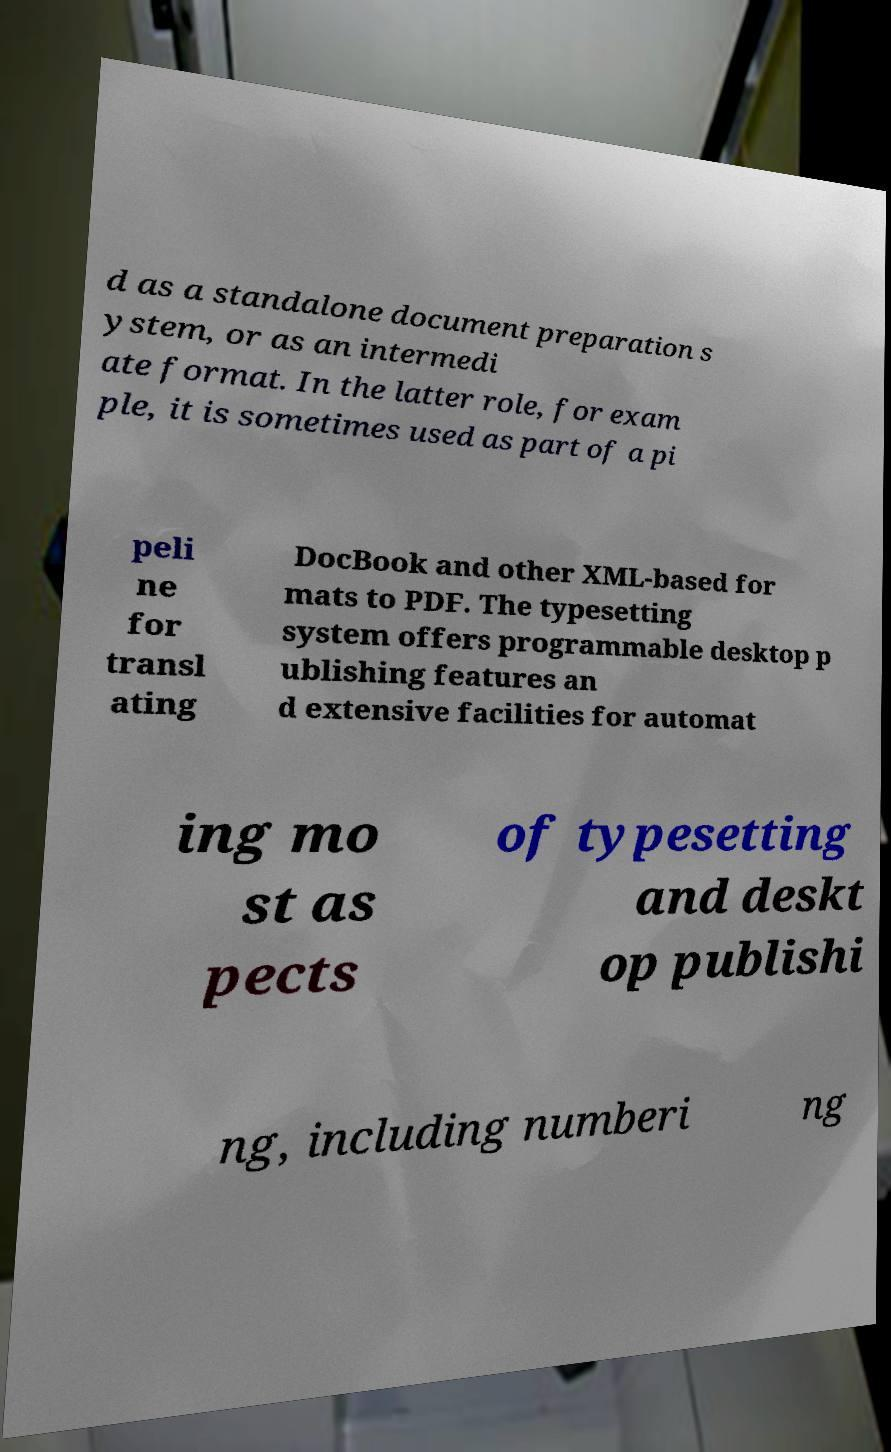Can you read and provide the text displayed in the image?This photo seems to have some interesting text. Can you extract and type it out for me? d as a standalone document preparation s ystem, or as an intermedi ate format. In the latter role, for exam ple, it is sometimes used as part of a pi peli ne for transl ating DocBook and other XML-based for mats to PDF. The typesetting system offers programmable desktop p ublishing features an d extensive facilities for automat ing mo st as pects of typesetting and deskt op publishi ng, including numberi ng 